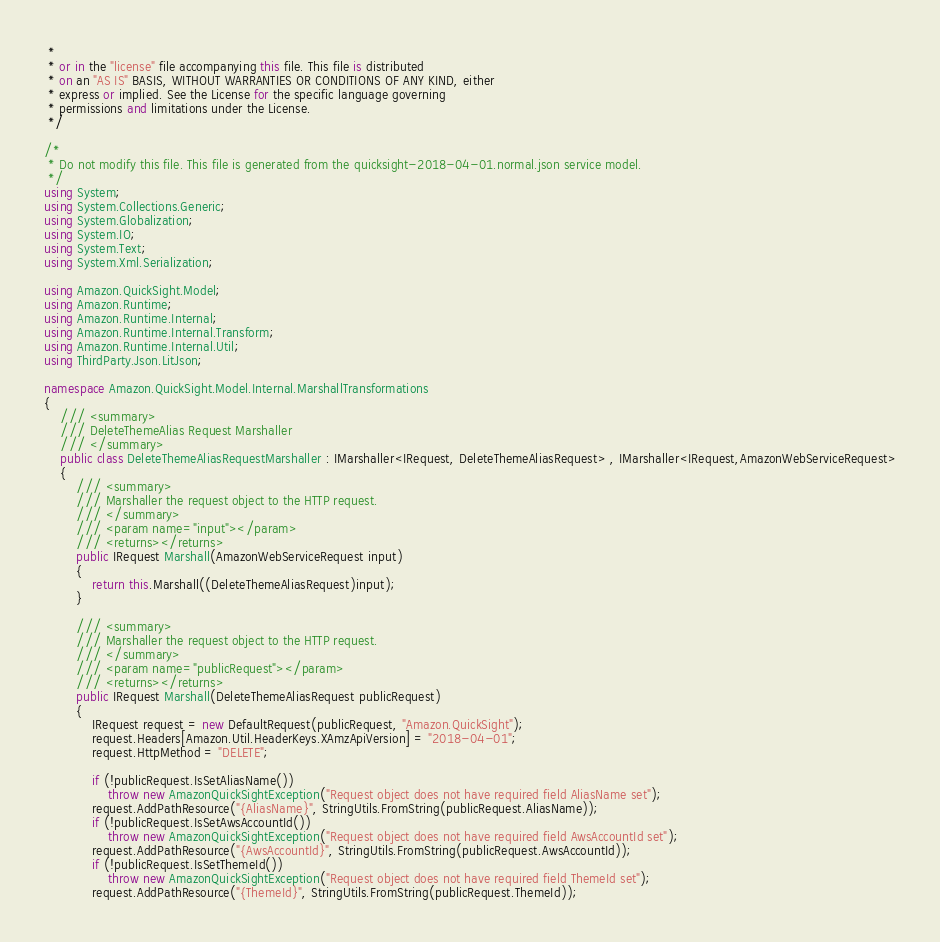Convert code to text. <code><loc_0><loc_0><loc_500><loc_500><_C#_> * 
 * or in the "license" file accompanying this file. This file is distributed
 * on an "AS IS" BASIS, WITHOUT WARRANTIES OR CONDITIONS OF ANY KIND, either
 * express or implied. See the License for the specific language governing
 * permissions and limitations under the License.
 */

/*
 * Do not modify this file. This file is generated from the quicksight-2018-04-01.normal.json service model.
 */
using System;
using System.Collections.Generic;
using System.Globalization;
using System.IO;
using System.Text;
using System.Xml.Serialization;

using Amazon.QuickSight.Model;
using Amazon.Runtime;
using Amazon.Runtime.Internal;
using Amazon.Runtime.Internal.Transform;
using Amazon.Runtime.Internal.Util;
using ThirdParty.Json.LitJson;

namespace Amazon.QuickSight.Model.Internal.MarshallTransformations
{
    /// <summary>
    /// DeleteThemeAlias Request Marshaller
    /// </summary>       
    public class DeleteThemeAliasRequestMarshaller : IMarshaller<IRequest, DeleteThemeAliasRequest> , IMarshaller<IRequest,AmazonWebServiceRequest>
    {
        /// <summary>
        /// Marshaller the request object to the HTTP request.
        /// </summary>  
        /// <param name="input"></param>
        /// <returns></returns>
        public IRequest Marshall(AmazonWebServiceRequest input)
        {
            return this.Marshall((DeleteThemeAliasRequest)input);
        }

        /// <summary>
        /// Marshaller the request object to the HTTP request.
        /// </summary>  
        /// <param name="publicRequest"></param>
        /// <returns></returns>
        public IRequest Marshall(DeleteThemeAliasRequest publicRequest)
        {
            IRequest request = new DefaultRequest(publicRequest, "Amazon.QuickSight");
            request.Headers[Amazon.Util.HeaderKeys.XAmzApiVersion] = "2018-04-01";            
            request.HttpMethod = "DELETE";

            if (!publicRequest.IsSetAliasName())
                throw new AmazonQuickSightException("Request object does not have required field AliasName set");
            request.AddPathResource("{AliasName}", StringUtils.FromString(publicRequest.AliasName));
            if (!publicRequest.IsSetAwsAccountId())
                throw new AmazonQuickSightException("Request object does not have required field AwsAccountId set");
            request.AddPathResource("{AwsAccountId}", StringUtils.FromString(publicRequest.AwsAccountId));
            if (!publicRequest.IsSetThemeId())
                throw new AmazonQuickSightException("Request object does not have required field ThemeId set");
            request.AddPathResource("{ThemeId}", StringUtils.FromString(publicRequest.ThemeId));</code> 